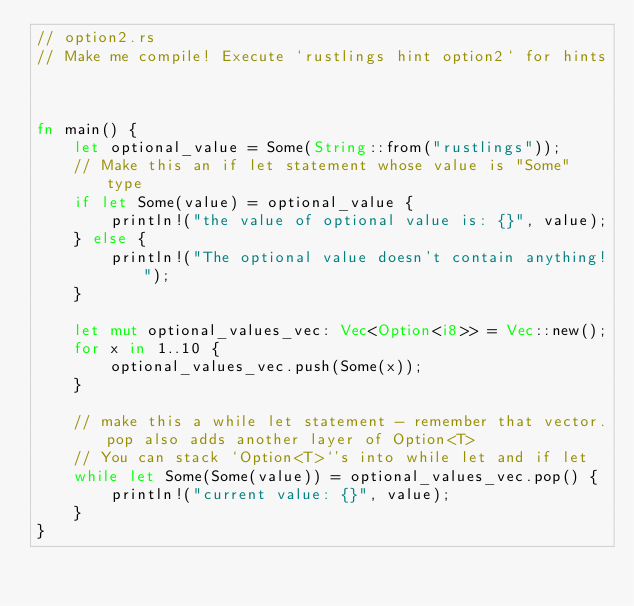Convert code to text. <code><loc_0><loc_0><loc_500><loc_500><_Rust_>// option2.rs
// Make me compile! Execute `rustlings hint option2` for hints



fn main() {
    let optional_value = Some(String::from("rustlings"));
    // Make this an if let statement whose value is "Some" type
    if let Some(value) = optional_value {
        println!("the value of optional value is: {}", value);
    } else {
        println!("The optional value doesn't contain anything!");
    }

    let mut optional_values_vec: Vec<Option<i8>> = Vec::new();
    for x in 1..10 {
        optional_values_vec.push(Some(x));
    }

    // make this a while let statement - remember that vector.pop also adds another layer of Option<T>
    // You can stack `Option<T>`'s into while let and if let
    while let Some(Some(value)) = optional_values_vec.pop() {
        println!("current value: {}", value);
    }
}
</code> 